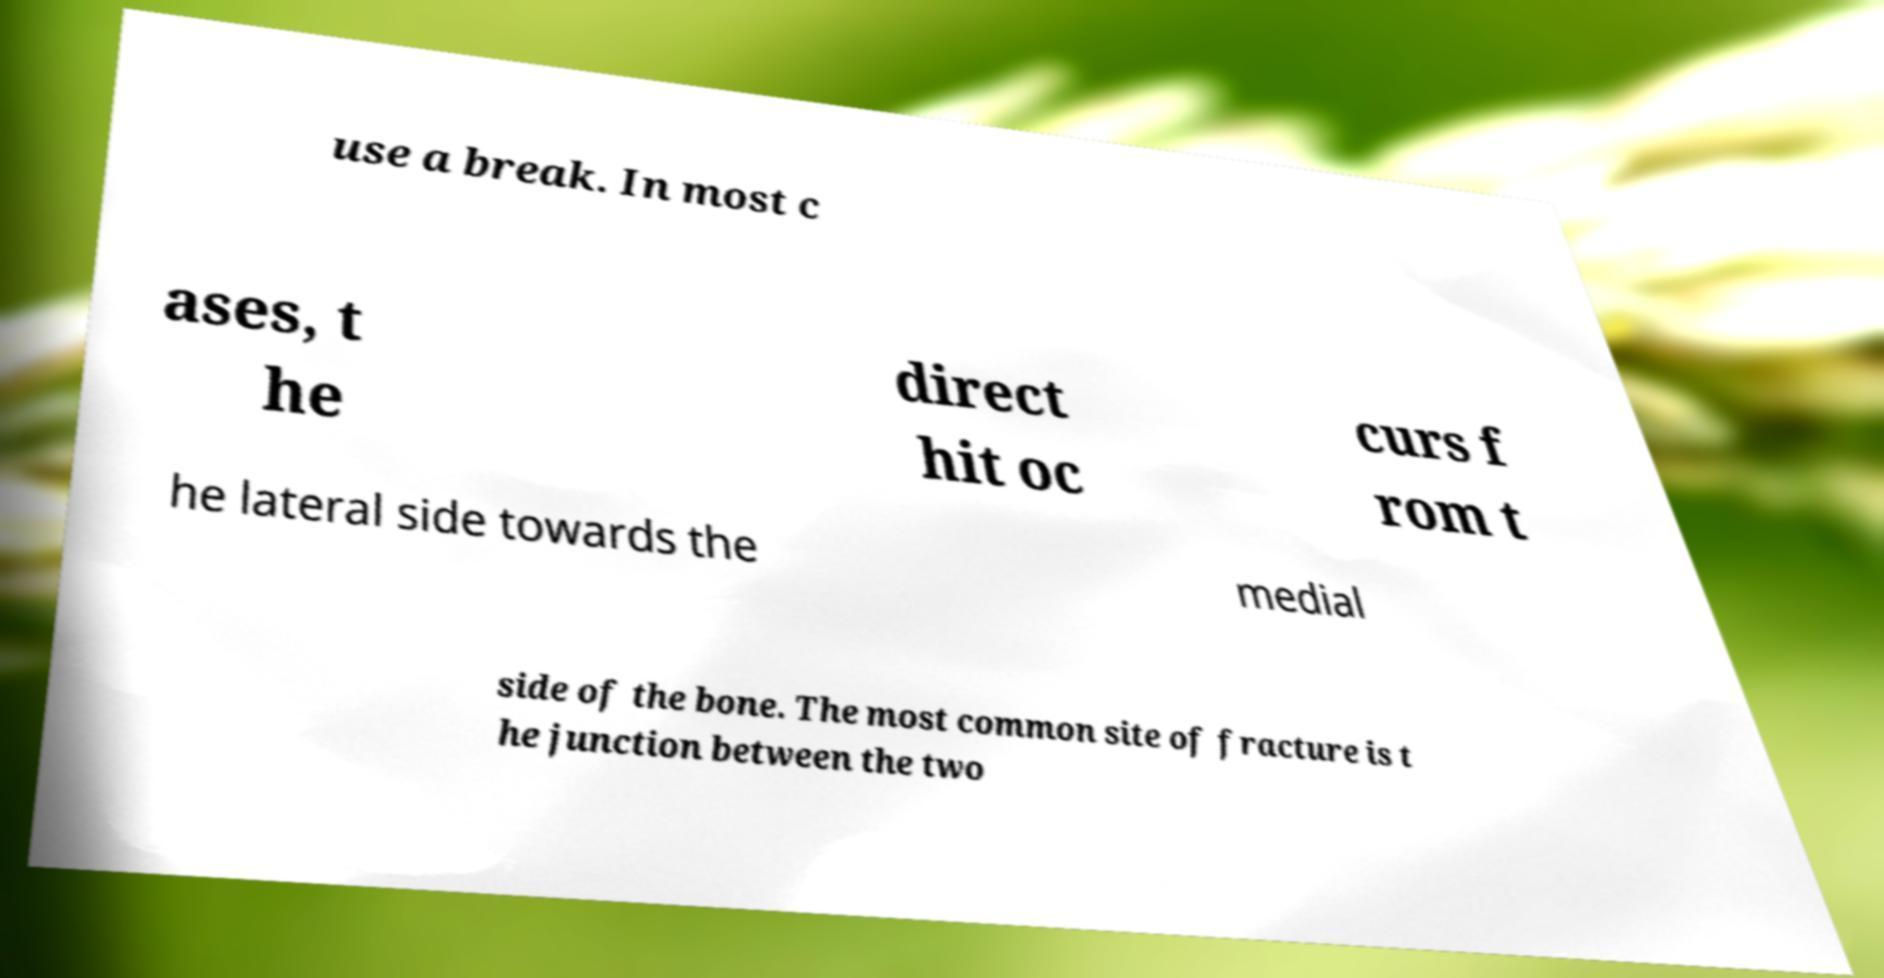For documentation purposes, I need the text within this image transcribed. Could you provide that? use a break. In most c ases, t he direct hit oc curs f rom t he lateral side towards the medial side of the bone. The most common site of fracture is t he junction between the two 